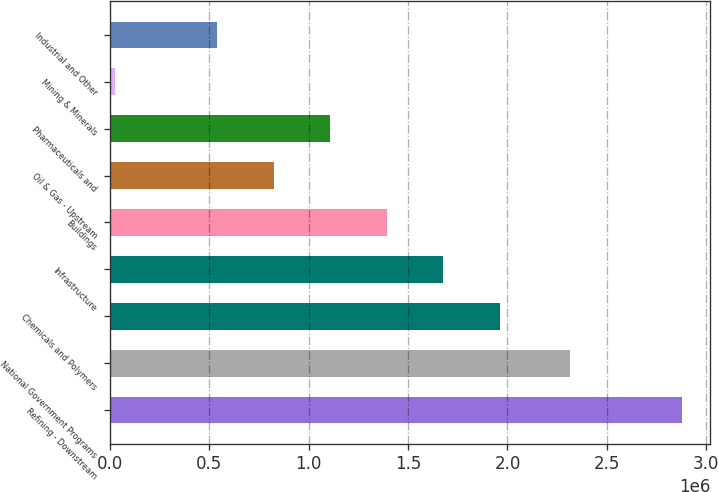<chart> <loc_0><loc_0><loc_500><loc_500><bar_chart><fcel>Refining - Downstream<fcel>National Government Programs<fcel>Chemicals and Polymers<fcel>Infrastructure<fcel>Buildings<fcel>Oil & Gas - Upstream<fcel>Pharmaceuticals and<fcel>Mining & Minerals<fcel>Industrial and Other<nl><fcel>2.87606e+06<fcel>2.31455e+06<fcel>1.96281e+06<fcel>1.67782e+06<fcel>1.39283e+06<fcel>822853<fcel>1.10784e+06<fcel>26161<fcel>537863<nl></chart> 